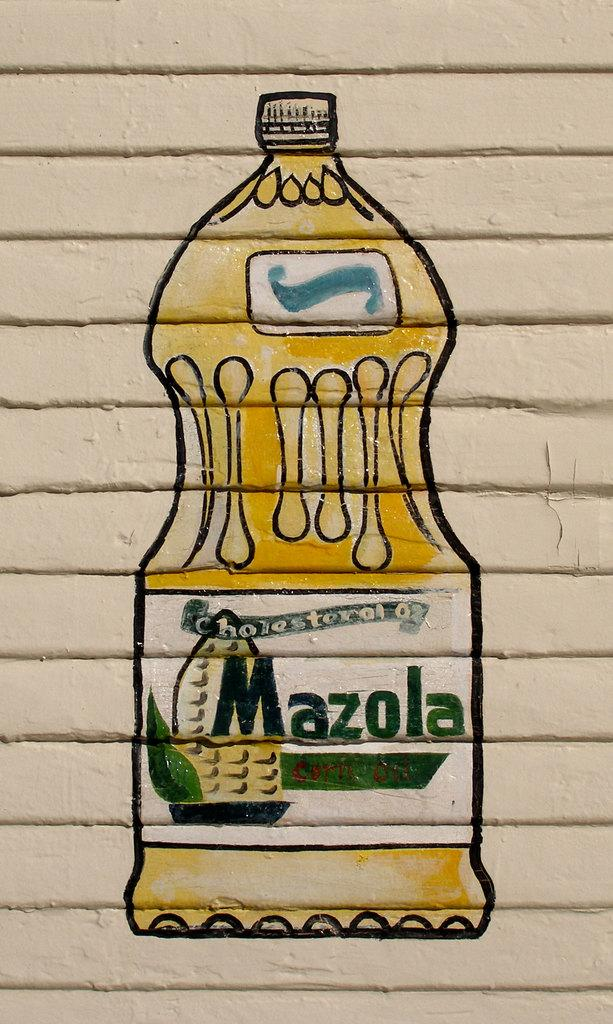<image>
Offer a succinct explanation of the picture presented. A drawing of Mazola corn oil is on the side of a building. 